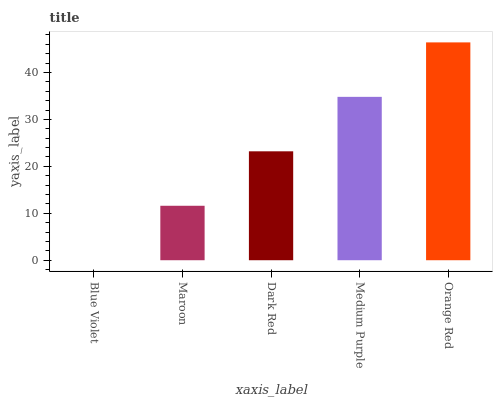Is Blue Violet the minimum?
Answer yes or no. Yes. Is Orange Red the maximum?
Answer yes or no. Yes. Is Maroon the minimum?
Answer yes or no. No. Is Maroon the maximum?
Answer yes or no. No. Is Maroon greater than Blue Violet?
Answer yes or no. Yes. Is Blue Violet less than Maroon?
Answer yes or no. Yes. Is Blue Violet greater than Maroon?
Answer yes or no. No. Is Maroon less than Blue Violet?
Answer yes or no. No. Is Dark Red the high median?
Answer yes or no. Yes. Is Dark Red the low median?
Answer yes or no. Yes. Is Blue Violet the high median?
Answer yes or no. No. Is Maroon the low median?
Answer yes or no. No. 